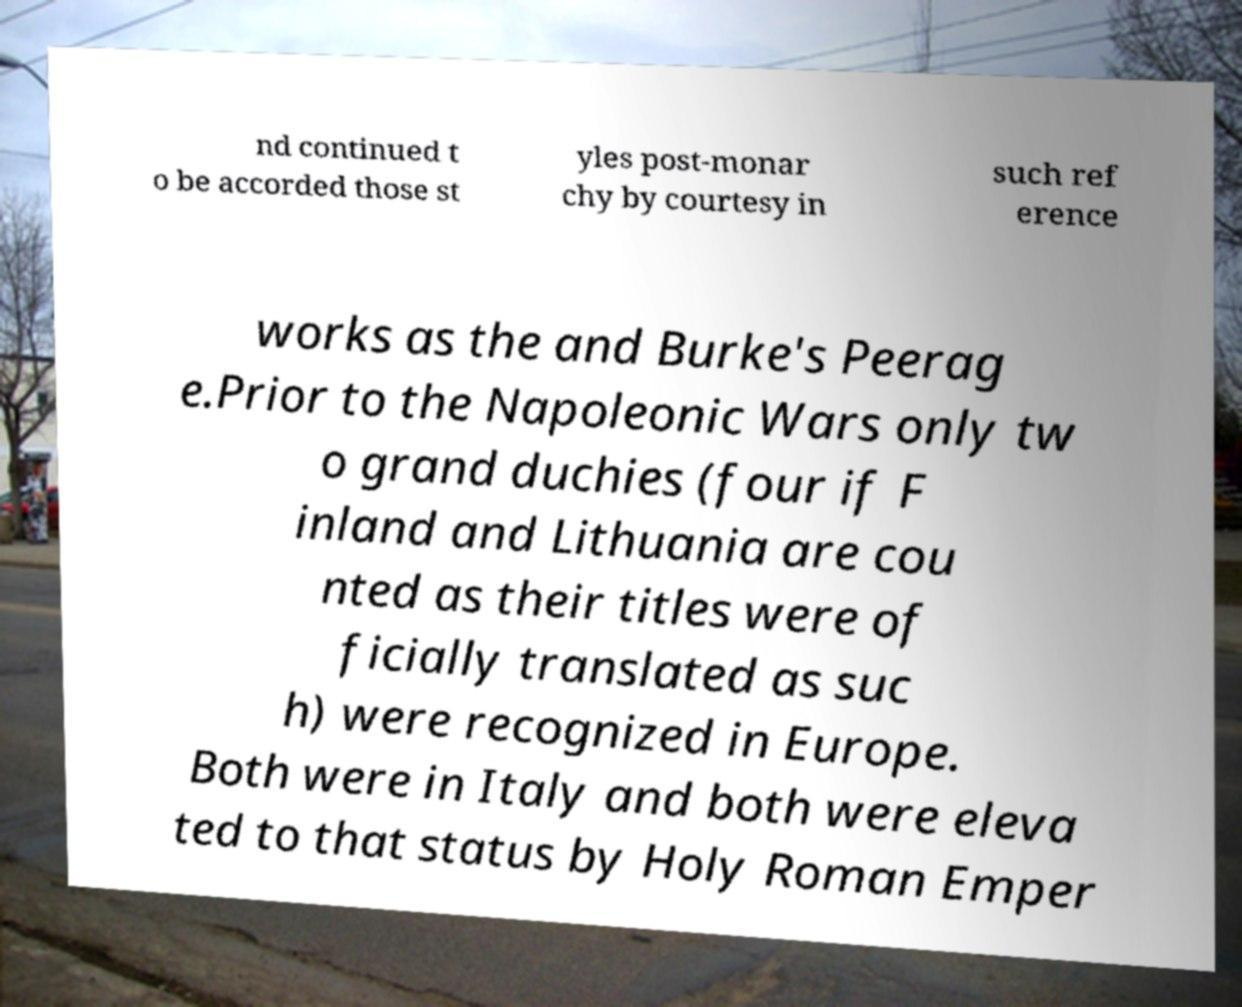Can you read and provide the text displayed in the image?This photo seems to have some interesting text. Can you extract and type it out for me? nd continued t o be accorded those st yles post-monar chy by courtesy in such ref erence works as the and Burke's Peerag e.Prior to the Napoleonic Wars only tw o grand duchies (four if F inland and Lithuania are cou nted as their titles were of ficially translated as suc h) were recognized in Europe. Both were in Italy and both were eleva ted to that status by Holy Roman Emper 